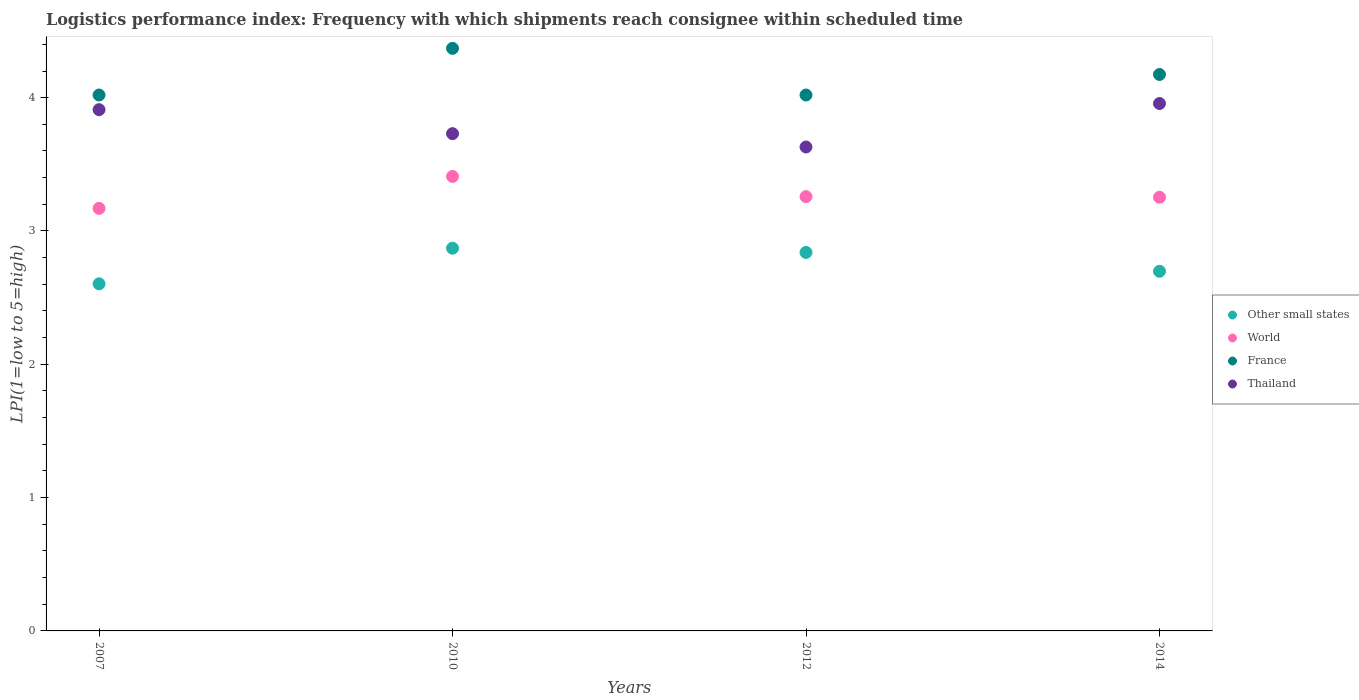Is the number of dotlines equal to the number of legend labels?
Provide a succinct answer. Yes. What is the logistics performance index in Thailand in 2014?
Keep it short and to the point. 3.96. Across all years, what is the maximum logistics performance index in Other small states?
Offer a very short reply. 2.87. Across all years, what is the minimum logistics performance index in France?
Provide a succinct answer. 4.02. In which year was the logistics performance index in Thailand minimum?
Keep it short and to the point. 2012. What is the total logistics performance index in Thailand in the graph?
Your response must be concise. 15.23. What is the difference between the logistics performance index in France in 2010 and that in 2014?
Offer a very short reply. 0.2. What is the difference between the logistics performance index in Other small states in 2014 and the logistics performance index in France in 2012?
Your answer should be compact. -1.32. What is the average logistics performance index in Thailand per year?
Offer a terse response. 3.81. In the year 2014, what is the difference between the logistics performance index in Thailand and logistics performance index in Other small states?
Keep it short and to the point. 1.26. What is the ratio of the logistics performance index in Thailand in 2010 to that in 2012?
Offer a very short reply. 1.03. Is the difference between the logistics performance index in Thailand in 2007 and 2010 greater than the difference between the logistics performance index in Other small states in 2007 and 2010?
Provide a short and direct response. Yes. What is the difference between the highest and the second highest logistics performance index in France?
Your response must be concise. 0.2. What is the difference between the highest and the lowest logistics performance index in World?
Provide a short and direct response. 0.24. In how many years, is the logistics performance index in France greater than the average logistics performance index in France taken over all years?
Offer a very short reply. 2. Is the sum of the logistics performance index in Other small states in 2007 and 2014 greater than the maximum logistics performance index in France across all years?
Offer a very short reply. Yes. Is it the case that in every year, the sum of the logistics performance index in France and logistics performance index in Other small states  is greater than the sum of logistics performance index in World and logistics performance index in Thailand?
Make the answer very short. Yes. Is it the case that in every year, the sum of the logistics performance index in France and logistics performance index in Thailand  is greater than the logistics performance index in Other small states?
Your answer should be compact. Yes. Does the logistics performance index in Thailand monotonically increase over the years?
Your answer should be compact. No. What is the difference between two consecutive major ticks on the Y-axis?
Give a very brief answer. 1. Are the values on the major ticks of Y-axis written in scientific E-notation?
Your answer should be very brief. No. Does the graph contain any zero values?
Offer a very short reply. No. Does the graph contain grids?
Provide a succinct answer. No. How many legend labels are there?
Offer a terse response. 4. What is the title of the graph?
Your answer should be compact. Logistics performance index: Frequency with which shipments reach consignee within scheduled time. What is the label or title of the Y-axis?
Provide a short and direct response. LPI(1=low to 5=high). What is the LPI(1=low to 5=high) in Other small states in 2007?
Provide a succinct answer. 2.6. What is the LPI(1=low to 5=high) in World in 2007?
Provide a succinct answer. 3.17. What is the LPI(1=low to 5=high) of France in 2007?
Your answer should be very brief. 4.02. What is the LPI(1=low to 5=high) of Thailand in 2007?
Keep it short and to the point. 3.91. What is the LPI(1=low to 5=high) in Other small states in 2010?
Your answer should be very brief. 2.87. What is the LPI(1=low to 5=high) in World in 2010?
Offer a very short reply. 3.41. What is the LPI(1=low to 5=high) of France in 2010?
Give a very brief answer. 4.37. What is the LPI(1=low to 5=high) of Thailand in 2010?
Keep it short and to the point. 3.73. What is the LPI(1=low to 5=high) in Other small states in 2012?
Offer a terse response. 2.84. What is the LPI(1=low to 5=high) in World in 2012?
Keep it short and to the point. 3.26. What is the LPI(1=low to 5=high) of France in 2012?
Your answer should be very brief. 4.02. What is the LPI(1=low to 5=high) of Thailand in 2012?
Ensure brevity in your answer.  3.63. What is the LPI(1=low to 5=high) of Other small states in 2014?
Provide a short and direct response. 2.7. What is the LPI(1=low to 5=high) in World in 2014?
Keep it short and to the point. 3.25. What is the LPI(1=low to 5=high) of France in 2014?
Ensure brevity in your answer.  4.17. What is the LPI(1=low to 5=high) in Thailand in 2014?
Ensure brevity in your answer.  3.96. Across all years, what is the maximum LPI(1=low to 5=high) in Other small states?
Your answer should be very brief. 2.87. Across all years, what is the maximum LPI(1=low to 5=high) in World?
Give a very brief answer. 3.41. Across all years, what is the maximum LPI(1=low to 5=high) in France?
Ensure brevity in your answer.  4.37. Across all years, what is the maximum LPI(1=low to 5=high) in Thailand?
Provide a succinct answer. 3.96. Across all years, what is the minimum LPI(1=low to 5=high) of Other small states?
Provide a short and direct response. 2.6. Across all years, what is the minimum LPI(1=low to 5=high) in World?
Ensure brevity in your answer.  3.17. Across all years, what is the minimum LPI(1=low to 5=high) in France?
Offer a very short reply. 4.02. Across all years, what is the minimum LPI(1=low to 5=high) in Thailand?
Provide a short and direct response. 3.63. What is the total LPI(1=low to 5=high) of Other small states in the graph?
Offer a terse response. 11.01. What is the total LPI(1=low to 5=high) of World in the graph?
Provide a short and direct response. 13.09. What is the total LPI(1=low to 5=high) in France in the graph?
Keep it short and to the point. 16.58. What is the total LPI(1=low to 5=high) in Thailand in the graph?
Offer a terse response. 15.23. What is the difference between the LPI(1=low to 5=high) in Other small states in 2007 and that in 2010?
Keep it short and to the point. -0.27. What is the difference between the LPI(1=low to 5=high) of World in 2007 and that in 2010?
Make the answer very short. -0.24. What is the difference between the LPI(1=low to 5=high) in France in 2007 and that in 2010?
Provide a succinct answer. -0.35. What is the difference between the LPI(1=low to 5=high) of Thailand in 2007 and that in 2010?
Your response must be concise. 0.18. What is the difference between the LPI(1=low to 5=high) of Other small states in 2007 and that in 2012?
Your response must be concise. -0.24. What is the difference between the LPI(1=low to 5=high) of World in 2007 and that in 2012?
Ensure brevity in your answer.  -0.09. What is the difference between the LPI(1=low to 5=high) of Thailand in 2007 and that in 2012?
Ensure brevity in your answer.  0.28. What is the difference between the LPI(1=low to 5=high) in Other small states in 2007 and that in 2014?
Make the answer very short. -0.09. What is the difference between the LPI(1=low to 5=high) of World in 2007 and that in 2014?
Make the answer very short. -0.08. What is the difference between the LPI(1=low to 5=high) in France in 2007 and that in 2014?
Give a very brief answer. -0.15. What is the difference between the LPI(1=low to 5=high) of Thailand in 2007 and that in 2014?
Offer a terse response. -0.05. What is the difference between the LPI(1=low to 5=high) in Other small states in 2010 and that in 2012?
Provide a short and direct response. 0.03. What is the difference between the LPI(1=low to 5=high) of World in 2010 and that in 2012?
Provide a succinct answer. 0.15. What is the difference between the LPI(1=low to 5=high) of France in 2010 and that in 2012?
Make the answer very short. 0.35. What is the difference between the LPI(1=low to 5=high) of Thailand in 2010 and that in 2012?
Give a very brief answer. 0.1. What is the difference between the LPI(1=low to 5=high) of Other small states in 2010 and that in 2014?
Provide a succinct answer. 0.17. What is the difference between the LPI(1=low to 5=high) in World in 2010 and that in 2014?
Provide a short and direct response. 0.16. What is the difference between the LPI(1=low to 5=high) of France in 2010 and that in 2014?
Provide a succinct answer. 0.2. What is the difference between the LPI(1=low to 5=high) in Thailand in 2010 and that in 2014?
Keep it short and to the point. -0.23. What is the difference between the LPI(1=low to 5=high) of Other small states in 2012 and that in 2014?
Your answer should be compact. 0.14. What is the difference between the LPI(1=low to 5=high) in World in 2012 and that in 2014?
Offer a very short reply. 0. What is the difference between the LPI(1=low to 5=high) in France in 2012 and that in 2014?
Provide a short and direct response. -0.15. What is the difference between the LPI(1=low to 5=high) in Thailand in 2012 and that in 2014?
Your answer should be very brief. -0.33. What is the difference between the LPI(1=low to 5=high) of Other small states in 2007 and the LPI(1=low to 5=high) of World in 2010?
Provide a succinct answer. -0.81. What is the difference between the LPI(1=low to 5=high) of Other small states in 2007 and the LPI(1=low to 5=high) of France in 2010?
Your answer should be compact. -1.77. What is the difference between the LPI(1=low to 5=high) in Other small states in 2007 and the LPI(1=low to 5=high) in Thailand in 2010?
Provide a succinct answer. -1.13. What is the difference between the LPI(1=low to 5=high) in World in 2007 and the LPI(1=low to 5=high) in France in 2010?
Offer a terse response. -1.2. What is the difference between the LPI(1=low to 5=high) in World in 2007 and the LPI(1=low to 5=high) in Thailand in 2010?
Provide a succinct answer. -0.56. What is the difference between the LPI(1=low to 5=high) of France in 2007 and the LPI(1=low to 5=high) of Thailand in 2010?
Your answer should be compact. 0.29. What is the difference between the LPI(1=low to 5=high) of Other small states in 2007 and the LPI(1=low to 5=high) of World in 2012?
Provide a succinct answer. -0.65. What is the difference between the LPI(1=low to 5=high) in Other small states in 2007 and the LPI(1=low to 5=high) in France in 2012?
Offer a very short reply. -1.42. What is the difference between the LPI(1=low to 5=high) in Other small states in 2007 and the LPI(1=low to 5=high) in Thailand in 2012?
Your response must be concise. -1.03. What is the difference between the LPI(1=low to 5=high) in World in 2007 and the LPI(1=low to 5=high) in France in 2012?
Your response must be concise. -0.85. What is the difference between the LPI(1=low to 5=high) in World in 2007 and the LPI(1=low to 5=high) in Thailand in 2012?
Provide a succinct answer. -0.46. What is the difference between the LPI(1=low to 5=high) in France in 2007 and the LPI(1=low to 5=high) in Thailand in 2012?
Give a very brief answer. 0.39. What is the difference between the LPI(1=low to 5=high) of Other small states in 2007 and the LPI(1=low to 5=high) of World in 2014?
Provide a succinct answer. -0.65. What is the difference between the LPI(1=low to 5=high) of Other small states in 2007 and the LPI(1=low to 5=high) of France in 2014?
Provide a short and direct response. -1.57. What is the difference between the LPI(1=low to 5=high) in Other small states in 2007 and the LPI(1=low to 5=high) in Thailand in 2014?
Provide a succinct answer. -1.35. What is the difference between the LPI(1=low to 5=high) in World in 2007 and the LPI(1=low to 5=high) in France in 2014?
Provide a short and direct response. -1. What is the difference between the LPI(1=low to 5=high) of World in 2007 and the LPI(1=low to 5=high) of Thailand in 2014?
Your answer should be compact. -0.79. What is the difference between the LPI(1=low to 5=high) in France in 2007 and the LPI(1=low to 5=high) in Thailand in 2014?
Make the answer very short. 0.06. What is the difference between the LPI(1=low to 5=high) in Other small states in 2010 and the LPI(1=low to 5=high) in World in 2012?
Keep it short and to the point. -0.39. What is the difference between the LPI(1=low to 5=high) in Other small states in 2010 and the LPI(1=low to 5=high) in France in 2012?
Your answer should be compact. -1.15. What is the difference between the LPI(1=low to 5=high) in Other small states in 2010 and the LPI(1=low to 5=high) in Thailand in 2012?
Your response must be concise. -0.76. What is the difference between the LPI(1=low to 5=high) in World in 2010 and the LPI(1=low to 5=high) in France in 2012?
Ensure brevity in your answer.  -0.61. What is the difference between the LPI(1=low to 5=high) in World in 2010 and the LPI(1=low to 5=high) in Thailand in 2012?
Give a very brief answer. -0.22. What is the difference between the LPI(1=low to 5=high) in France in 2010 and the LPI(1=low to 5=high) in Thailand in 2012?
Provide a short and direct response. 0.74. What is the difference between the LPI(1=low to 5=high) of Other small states in 2010 and the LPI(1=low to 5=high) of World in 2014?
Ensure brevity in your answer.  -0.38. What is the difference between the LPI(1=low to 5=high) of Other small states in 2010 and the LPI(1=low to 5=high) of France in 2014?
Offer a very short reply. -1.3. What is the difference between the LPI(1=low to 5=high) of Other small states in 2010 and the LPI(1=low to 5=high) of Thailand in 2014?
Keep it short and to the point. -1.09. What is the difference between the LPI(1=low to 5=high) in World in 2010 and the LPI(1=low to 5=high) in France in 2014?
Keep it short and to the point. -0.76. What is the difference between the LPI(1=low to 5=high) of World in 2010 and the LPI(1=low to 5=high) of Thailand in 2014?
Offer a very short reply. -0.55. What is the difference between the LPI(1=low to 5=high) of France in 2010 and the LPI(1=low to 5=high) of Thailand in 2014?
Provide a succinct answer. 0.41. What is the difference between the LPI(1=low to 5=high) of Other small states in 2012 and the LPI(1=low to 5=high) of World in 2014?
Your answer should be compact. -0.41. What is the difference between the LPI(1=low to 5=high) of Other small states in 2012 and the LPI(1=low to 5=high) of France in 2014?
Your answer should be compact. -1.33. What is the difference between the LPI(1=low to 5=high) of Other small states in 2012 and the LPI(1=low to 5=high) of Thailand in 2014?
Give a very brief answer. -1.12. What is the difference between the LPI(1=low to 5=high) in World in 2012 and the LPI(1=low to 5=high) in France in 2014?
Offer a terse response. -0.92. What is the difference between the LPI(1=low to 5=high) of World in 2012 and the LPI(1=low to 5=high) of Thailand in 2014?
Offer a terse response. -0.7. What is the difference between the LPI(1=low to 5=high) in France in 2012 and the LPI(1=low to 5=high) in Thailand in 2014?
Ensure brevity in your answer.  0.06. What is the average LPI(1=low to 5=high) in Other small states per year?
Your response must be concise. 2.75. What is the average LPI(1=low to 5=high) of World per year?
Your answer should be very brief. 3.27. What is the average LPI(1=low to 5=high) of France per year?
Offer a terse response. 4.15. What is the average LPI(1=low to 5=high) of Thailand per year?
Provide a succinct answer. 3.81. In the year 2007, what is the difference between the LPI(1=low to 5=high) of Other small states and LPI(1=low to 5=high) of World?
Offer a terse response. -0.57. In the year 2007, what is the difference between the LPI(1=low to 5=high) in Other small states and LPI(1=low to 5=high) in France?
Offer a terse response. -1.42. In the year 2007, what is the difference between the LPI(1=low to 5=high) of Other small states and LPI(1=low to 5=high) of Thailand?
Keep it short and to the point. -1.31. In the year 2007, what is the difference between the LPI(1=low to 5=high) in World and LPI(1=low to 5=high) in France?
Provide a short and direct response. -0.85. In the year 2007, what is the difference between the LPI(1=low to 5=high) of World and LPI(1=low to 5=high) of Thailand?
Offer a terse response. -0.74. In the year 2007, what is the difference between the LPI(1=low to 5=high) of France and LPI(1=low to 5=high) of Thailand?
Provide a succinct answer. 0.11. In the year 2010, what is the difference between the LPI(1=low to 5=high) in Other small states and LPI(1=low to 5=high) in World?
Provide a short and direct response. -0.54. In the year 2010, what is the difference between the LPI(1=low to 5=high) in Other small states and LPI(1=low to 5=high) in France?
Offer a very short reply. -1.5. In the year 2010, what is the difference between the LPI(1=low to 5=high) in Other small states and LPI(1=low to 5=high) in Thailand?
Make the answer very short. -0.86. In the year 2010, what is the difference between the LPI(1=low to 5=high) of World and LPI(1=low to 5=high) of France?
Provide a succinct answer. -0.96. In the year 2010, what is the difference between the LPI(1=low to 5=high) of World and LPI(1=low to 5=high) of Thailand?
Ensure brevity in your answer.  -0.32. In the year 2010, what is the difference between the LPI(1=low to 5=high) in France and LPI(1=low to 5=high) in Thailand?
Offer a very short reply. 0.64. In the year 2012, what is the difference between the LPI(1=low to 5=high) in Other small states and LPI(1=low to 5=high) in World?
Your response must be concise. -0.42. In the year 2012, what is the difference between the LPI(1=low to 5=high) of Other small states and LPI(1=low to 5=high) of France?
Make the answer very short. -1.18. In the year 2012, what is the difference between the LPI(1=low to 5=high) in Other small states and LPI(1=low to 5=high) in Thailand?
Keep it short and to the point. -0.79. In the year 2012, what is the difference between the LPI(1=low to 5=high) of World and LPI(1=low to 5=high) of France?
Make the answer very short. -0.76. In the year 2012, what is the difference between the LPI(1=low to 5=high) of World and LPI(1=low to 5=high) of Thailand?
Ensure brevity in your answer.  -0.37. In the year 2012, what is the difference between the LPI(1=low to 5=high) in France and LPI(1=low to 5=high) in Thailand?
Provide a succinct answer. 0.39. In the year 2014, what is the difference between the LPI(1=low to 5=high) of Other small states and LPI(1=low to 5=high) of World?
Your answer should be very brief. -0.56. In the year 2014, what is the difference between the LPI(1=low to 5=high) of Other small states and LPI(1=low to 5=high) of France?
Ensure brevity in your answer.  -1.48. In the year 2014, what is the difference between the LPI(1=low to 5=high) of Other small states and LPI(1=low to 5=high) of Thailand?
Your answer should be very brief. -1.26. In the year 2014, what is the difference between the LPI(1=low to 5=high) of World and LPI(1=low to 5=high) of France?
Keep it short and to the point. -0.92. In the year 2014, what is the difference between the LPI(1=low to 5=high) in World and LPI(1=low to 5=high) in Thailand?
Your response must be concise. -0.7. In the year 2014, what is the difference between the LPI(1=low to 5=high) of France and LPI(1=low to 5=high) of Thailand?
Offer a terse response. 0.22. What is the ratio of the LPI(1=low to 5=high) in Other small states in 2007 to that in 2010?
Provide a succinct answer. 0.91. What is the ratio of the LPI(1=low to 5=high) of World in 2007 to that in 2010?
Provide a succinct answer. 0.93. What is the ratio of the LPI(1=low to 5=high) in France in 2007 to that in 2010?
Your response must be concise. 0.92. What is the ratio of the LPI(1=low to 5=high) of Thailand in 2007 to that in 2010?
Keep it short and to the point. 1.05. What is the ratio of the LPI(1=low to 5=high) in Other small states in 2007 to that in 2012?
Provide a short and direct response. 0.92. What is the ratio of the LPI(1=low to 5=high) in World in 2007 to that in 2012?
Ensure brevity in your answer.  0.97. What is the ratio of the LPI(1=low to 5=high) in Thailand in 2007 to that in 2012?
Give a very brief answer. 1.08. What is the ratio of the LPI(1=low to 5=high) of Other small states in 2007 to that in 2014?
Offer a terse response. 0.97. What is the ratio of the LPI(1=low to 5=high) in World in 2007 to that in 2014?
Provide a succinct answer. 0.97. What is the ratio of the LPI(1=low to 5=high) in France in 2007 to that in 2014?
Provide a succinct answer. 0.96. What is the ratio of the LPI(1=low to 5=high) of Thailand in 2007 to that in 2014?
Offer a very short reply. 0.99. What is the ratio of the LPI(1=low to 5=high) of Other small states in 2010 to that in 2012?
Your response must be concise. 1.01. What is the ratio of the LPI(1=low to 5=high) of World in 2010 to that in 2012?
Your response must be concise. 1.05. What is the ratio of the LPI(1=low to 5=high) of France in 2010 to that in 2012?
Give a very brief answer. 1.09. What is the ratio of the LPI(1=low to 5=high) of Thailand in 2010 to that in 2012?
Provide a short and direct response. 1.03. What is the ratio of the LPI(1=low to 5=high) in Other small states in 2010 to that in 2014?
Give a very brief answer. 1.06. What is the ratio of the LPI(1=low to 5=high) in World in 2010 to that in 2014?
Keep it short and to the point. 1.05. What is the ratio of the LPI(1=low to 5=high) of France in 2010 to that in 2014?
Your answer should be compact. 1.05. What is the ratio of the LPI(1=low to 5=high) in Thailand in 2010 to that in 2014?
Keep it short and to the point. 0.94. What is the ratio of the LPI(1=low to 5=high) in Other small states in 2012 to that in 2014?
Your answer should be compact. 1.05. What is the ratio of the LPI(1=low to 5=high) of France in 2012 to that in 2014?
Give a very brief answer. 0.96. What is the ratio of the LPI(1=low to 5=high) in Thailand in 2012 to that in 2014?
Offer a terse response. 0.92. What is the difference between the highest and the second highest LPI(1=low to 5=high) in Other small states?
Offer a terse response. 0.03. What is the difference between the highest and the second highest LPI(1=low to 5=high) of World?
Provide a short and direct response. 0.15. What is the difference between the highest and the second highest LPI(1=low to 5=high) in France?
Provide a short and direct response. 0.2. What is the difference between the highest and the second highest LPI(1=low to 5=high) in Thailand?
Provide a succinct answer. 0.05. What is the difference between the highest and the lowest LPI(1=low to 5=high) in Other small states?
Provide a succinct answer. 0.27. What is the difference between the highest and the lowest LPI(1=low to 5=high) of World?
Your answer should be very brief. 0.24. What is the difference between the highest and the lowest LPI(1=low to 5=high) of Thailand?
Provide a succinct answer. 0.33. 